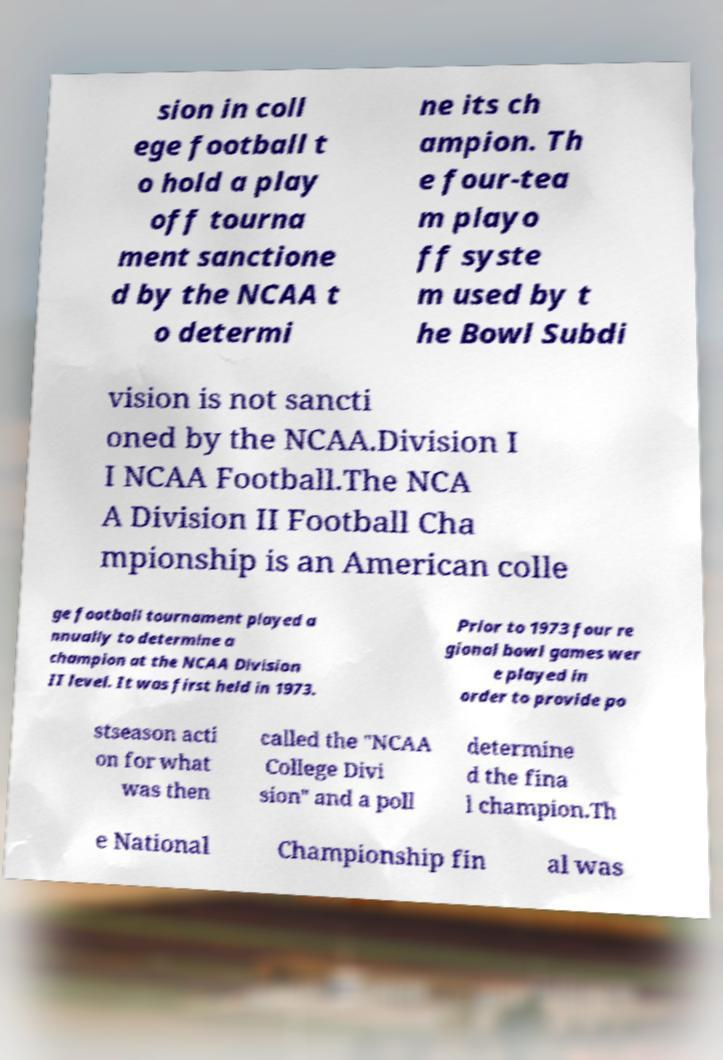Please identify and transcribe the text found in this image. sion in coll ege football t o hold a play off tourna ment sanctione d by the NCAA t o determi ne its ch ampion. Th e four-tea m playo ff syste m used by t he Bowl Subdi vision is not sancti oned by the NCAA.Division I I NCAA Football.The NCA A Division II Football Cha mpionship is an American colle ge football tournament played a nnually to determine a champion at the NCAA Division II level. It was first held in 1973. Prior to 1973 four re gional bowl games wer e played in order to provide po stseason acti on for what was then called the "NCAA College Divi sion" and a poll determine d the fina l champion.Th e National Championship fin al was 